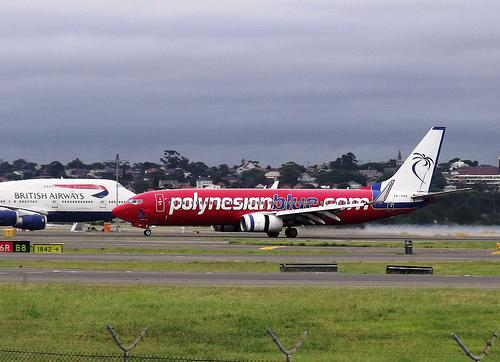Question: who is in the photo?
Choices:
A. Boy scout troup.
B. Nobody.
C. First grade class.
D. Highschool English class.
Answer with the letter. Answer: B Question: how many airplanes are visible?
Choices:
A. 2.
B. 4.
C. 3.
D. 8.
Answer with the letter. Answer: A Question: what color is the runway?
Choices:
A. Yellow.
B. White.
C. Gray.
D. Green.
Answer with the letter. Answer: C 